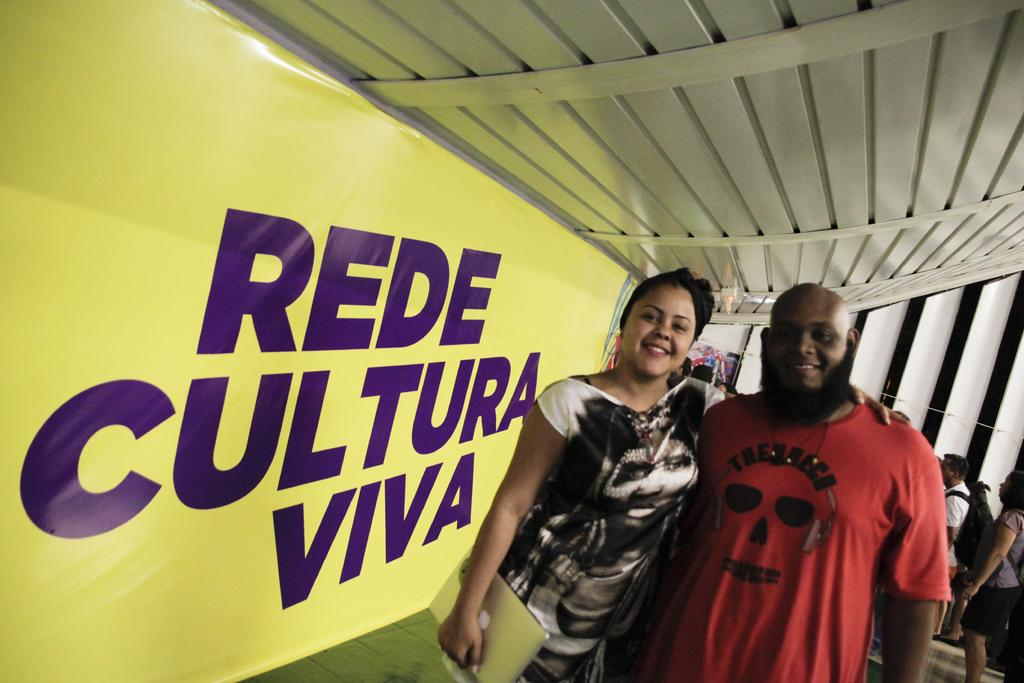How many people are in the image? There are two persons in the image. Can you describe the gender of the individuals? One of the persons is a woman, and the other person is a man. What are the positions of the woman and the man in the image? Both the woman and the man are standing. What object is the woman holding in the image? The woman is holding a laptop. What type of screw can be seen in the woman's hair in the image? There is no screw present in the woman's hair or in the image. What is the woman's state of mind in the image? The image does not provide information about the woman's state of mind. --- Facts: 1. There is a car in the image. 2. The car is red. 3. The car has four wheels. 4. The car has a license plate. 5. The car is parked on the street. Absurd Topics: bird, ocean, mountain Conversation: What is the main subject of the image? The main subject of the image is a car. What color is the car? The car is red. How many wheels does the car have? The car has four wheels. Does the car have any identifying features? Yes, the car has a license plate. Where is the car located in the image? The car is parked on the street. Reasoning: Let's think step by step in order to produce the conversation. We start by identifying the main subject of the image, which is the car. Then, we describe the color and number of wheels of the car. Next, we mention the identifying feature of the car, which is the license plate. Finally, we describe the location of the car in the image, stating that it is parked on the street. Absurd Question/Answer: Can you see any mountains in the background of the image? There are no mountains visible in the image; it features a red car parked on the street. What type of bird is sitting on the car's hood in the image? There is no bird present on the car's hood or in the image. 